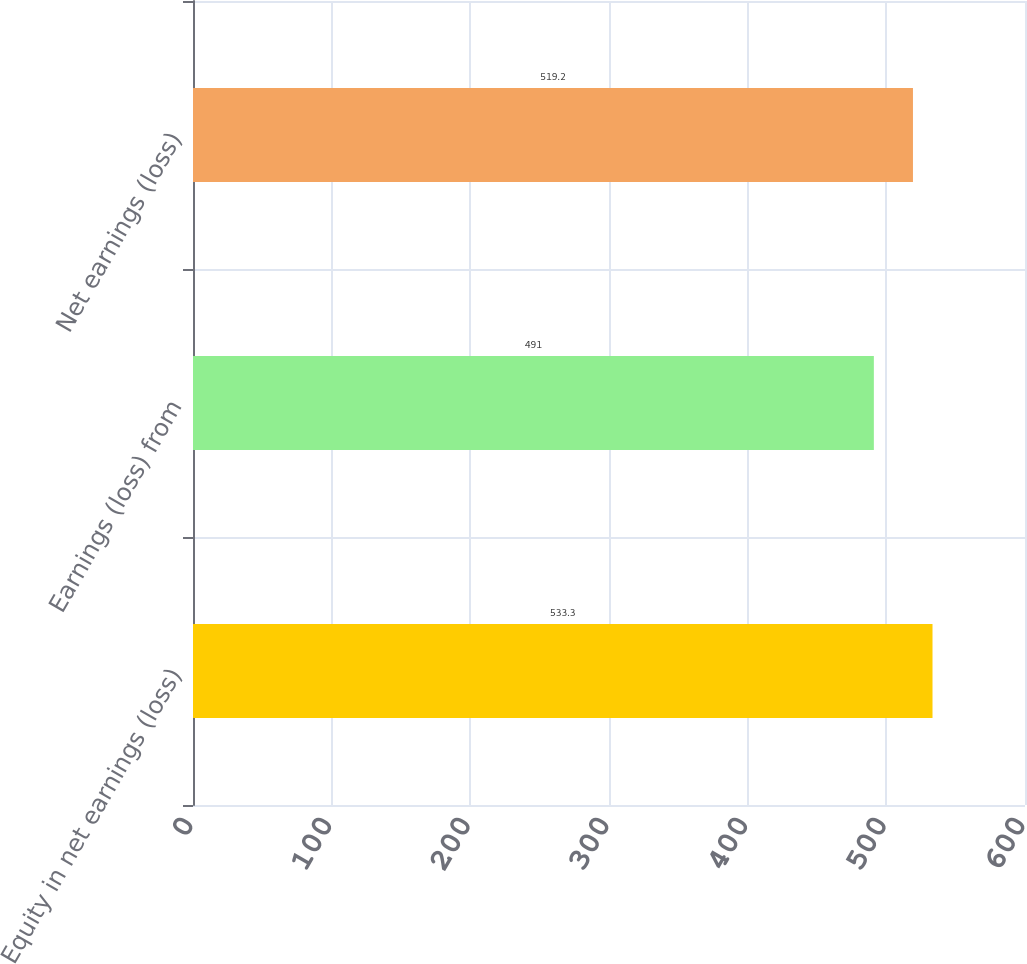Convert chart to OTSL. <chart><loc_0><loc_0><loc_500><loc_500><bar_chart><fcel>Equity in net earnings (loss)<fcel>Earnings (loss) from<fcel>Net earnings (loss)<nl><fcel>533.3<fcel>491<fcel>519.2<nl></chart> 